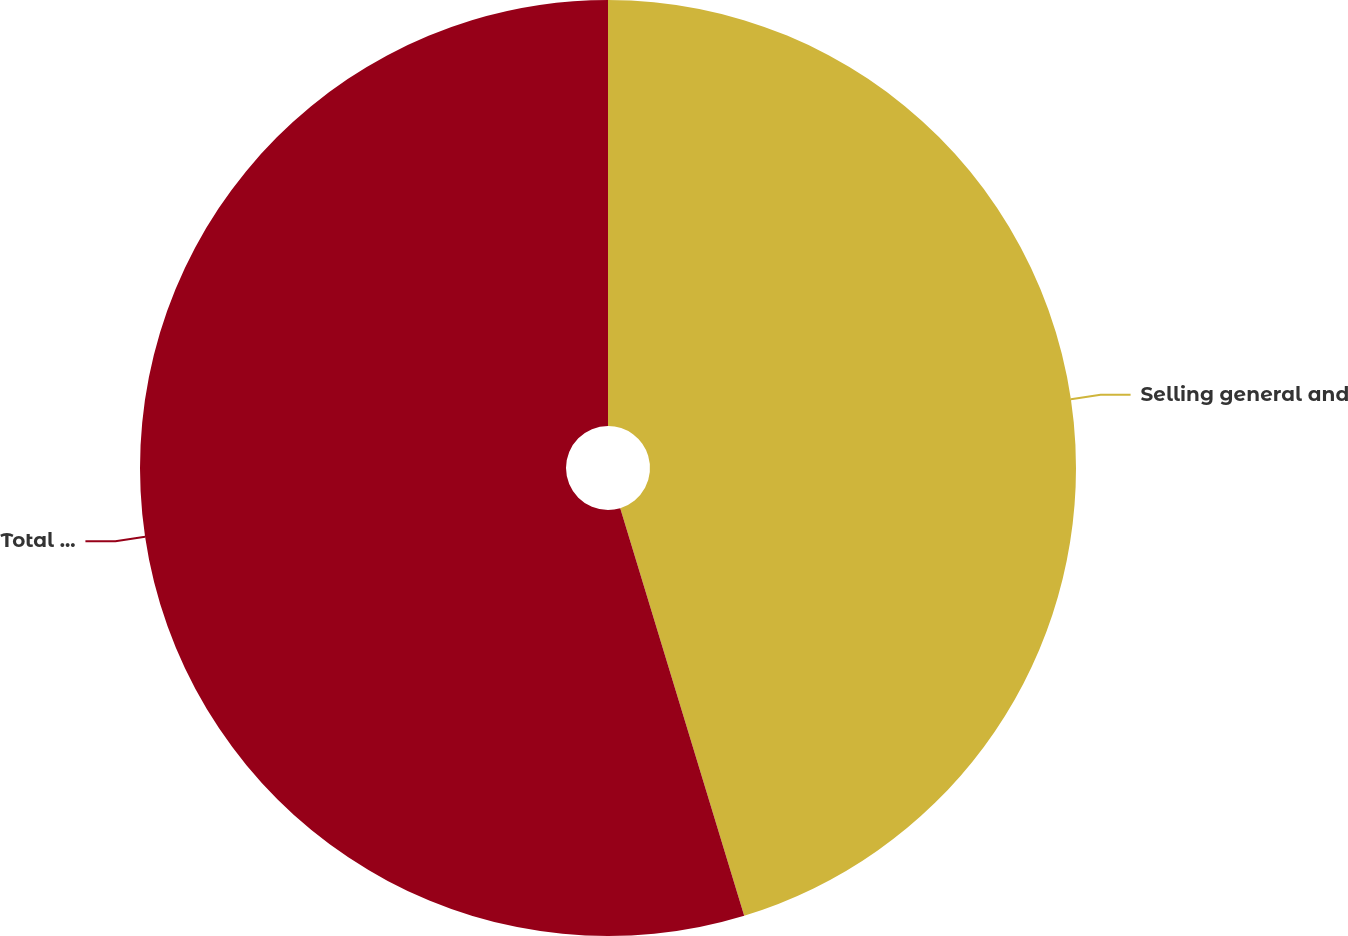Convert chart. <chart><loc_0><loc_0><loc_500><loc_500><pie_chart><fcel>Selling general and<fcel>Total restructuring asset<nl><fcel>45.3%<fcel>54.7%<nl></chart> 